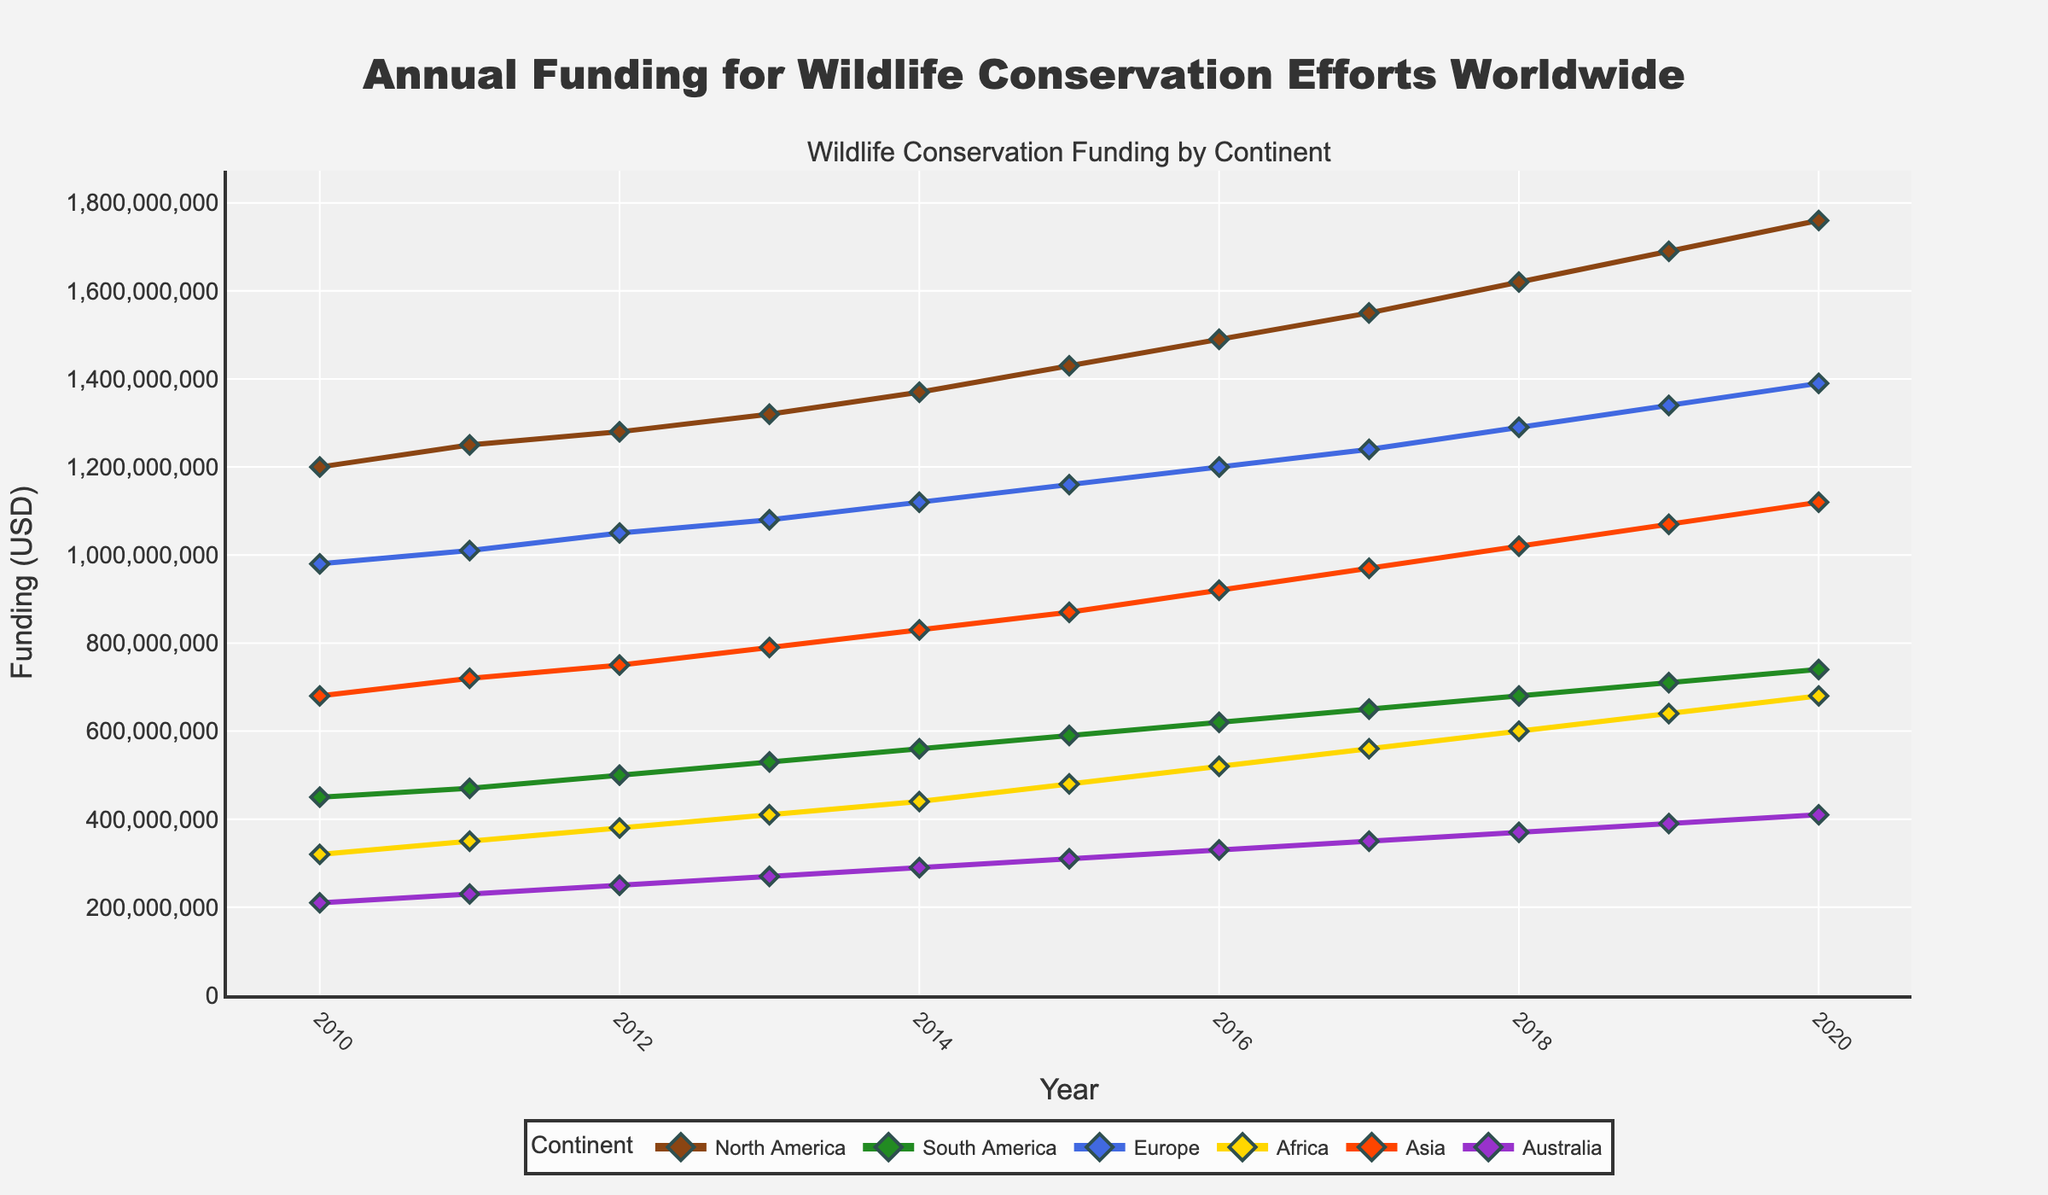Which continent received the highest funding in 2020? By comparing the funding amounts for each continent in 2020, we see that Europe received the highest funding.
Answer: Europe What is the difference in funding between North America and Africa in 2015? The funding for North America in 2015 is $1,430,000,000 and for Africa is $480,000,000. The difference is $1,430,000,000 - $480,000,000 = $950,000,000.
Answer: $950,000,000 Which continent had the least increase in funding from 2010 to 2020? By calculating the difference between the funding in 2020 and 2010 for each continent, Australia had the least increase: $410,000,000 - $210,000,000 = $200,000,000.
Answer: Australia What is the average annual funding for Asia over the decade? Adding the annual funding for Asia from 2010 to 2020 gives $680,000,000 + $720,000,000 + $750,000,000 + $790,000,000 + $830,000,000 + $870,000,000 + $920,000,000 + $970,000,000 + $1,020,000,000 + $1,070,000,000 + $1,120,000,000 = $9,740,000,000. Dividing by 11 gives the average annual funding: $9,740,000,000 / 11 ≈ $885,454,545.45.
Answer: ~$885,454,545.45 Which year did South America see the highest relative increase in funding compared to the previous year? The highest relative increase can be calculated as ((funding in the current year - funding in the previous year) / funding in the previous year). From the data, 2018 saw the highest increase where it rose from $650,000,000 in 2017 to $680,000,000 in 2018. This is an increase of (($680,000,000 - $650,000,000) / $650,000,000) ≈ 0.046 or 4.6%.
Answer: 2018 How much did the total funding for all continents increase from 2011 to 2015? Summing the funding for 2011 and 2015: 2011 = $1,250,000,000 + $470,000,000 + $1,010,000,000 + $350,000,000 + $720,000,000 + $230,000,000 = $4,030,000,000; 2015 = $1,430,000,000 + $590,000,000 + $1,160,000,000 + $480,000,000 + $870,000,000 + $310,000,000 = $4,840,000,000. The increase is $4,840,000,000 - $4,030,000,000 = $810,000,000.
Answer: $810,000,000 Which continent's funding showed the most stable growth over the decade? By examining the trends, North America shows the most consistent annual increase with no significant dips or jumps in the funding amount each year.
Answer: North America In which year did all continents collectively receive over $6 billion in funding for the first time? Summing the annual funding for each year, the first instance where the total funding exceeds $6 billion occurs in 2016: $1,490,000,000 + $620,000,000 + $1,200,000,000 + $520,000,000 + $920,000,000 + $330,000,000 = $6,080,000,000.
Answer: 2016 What was the total funding for wildlife conservation efforts worldwide in 2012? Summing the funding for all continents in 2012 gives $1,280,000,000 + $500,000,000 + $1,050,000,000 + $380,000,000 + $750,000,000 + $250,000,000 = $4,210,000,000.
Answer: $4,210,000,000 